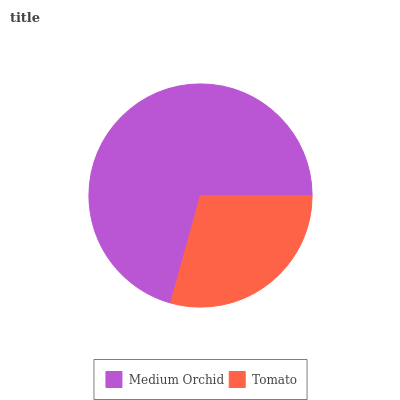Is Tomato the minimum?
Answer yes or no. Yes. Is Medium Orchid the maximum?
Answer yes or no. Yes. Is Tomato the maximum?
Answer yes or no. No. Is Medium Orchid greater than Tomato?
Answer yes or no. Yes. Is Tomato less than Medium Orchid?
Answer yes or no. Yes. Is Tomato greater than Medium Orchid?
Answer yes or no. No. Is Medium Orchid less than Tomato?
Answer yes or no. No. Is Medium Orchid the high median?
Answer yes or no. Yes. Is Tomato the low median?
Answer yes or no. Yes. Is Tomato the high median?
Answer yes or no. No. Is Medium Orchid the low median?
Answer yes or no. No. 